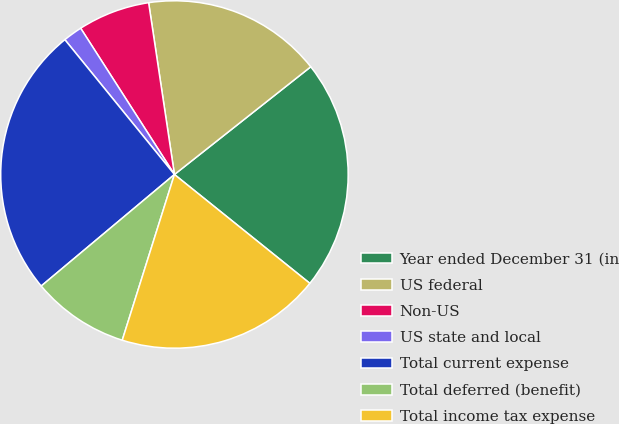<chart> <loc_0><loc_0><loc_500><loc_500><pie_chart><fcel>Year ended December 31 (in<fcel>US federal<fcel>Non-US<fcel>US state and local<fcel>Total current expense<fcel>Total deferred (benefit)<fcel>Total income tax expense<nl><fcel>21.42%<fcel>16.73%<fcel>6.7%<fcel>1.79%<fcel>25.23%<fcel>9.05%<fcel>19.08%<nl></chart> 